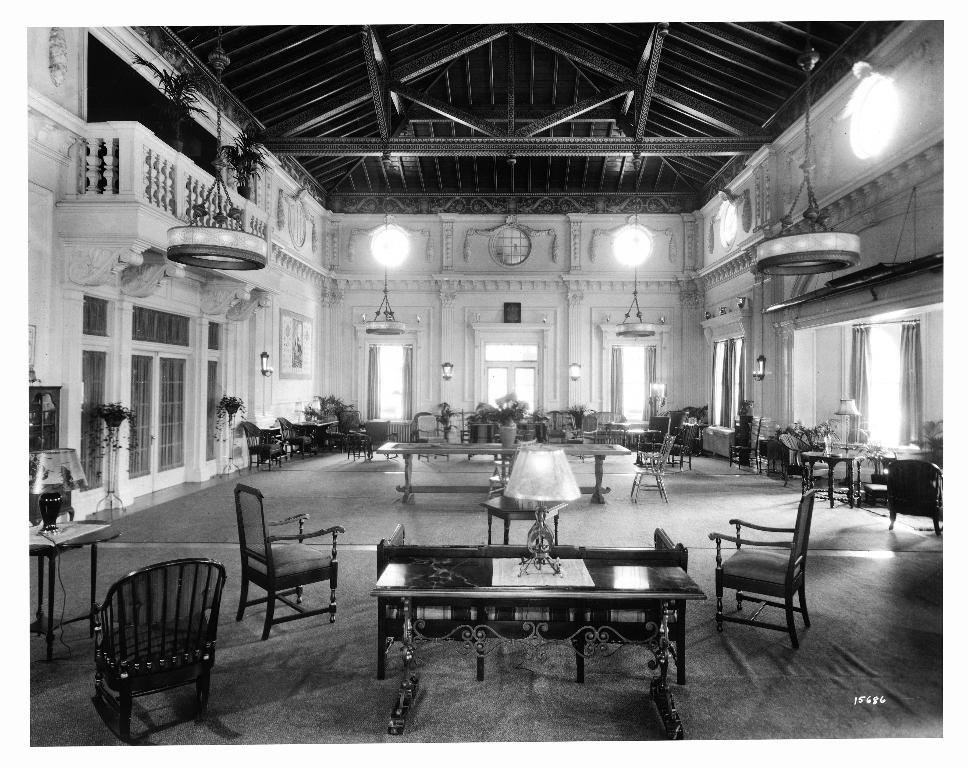What type of furniture is present in the image? There are tables and chairs in the image. What type of decorative elements can be seen in the image? There are houseplants in the image. What architectural features are visible in the image? There are windows in the image. What type of lighting is present in the image? There are lights in the image. What can be inferred about the location of the image? The image is an inside view of a building. Where is the seed located in the image? There is no seed present in the image. What type of gun can be seen in the image? There is no gun present in the image. 